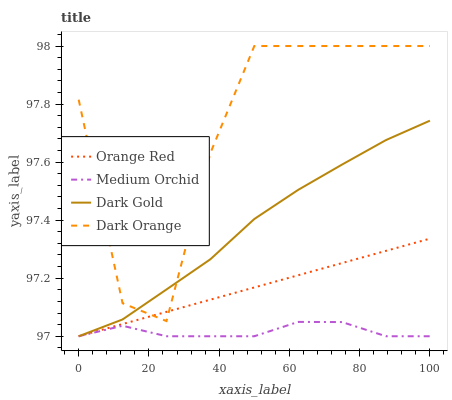Does Orange Red have the minimum area under the curve?
Answer yes or no. No. Does Orange Red have the maximum area under the curve?
Answer yes or no. No. Is Medium Orchid the smoothest?
Answer yes or no. No. Is Medium Orchid the roughest?
Answer yes or no. No. Does Orange Red have the highest value?
Answer yes or no. No. Is Medium Orchid less than Dark Orange?
Answer yes or no. Yes. Is Dark Orange greater than Medium Orchid?
Answer yes or no. Yes. Does Medium Orchid intersect Dark Orange?
Answer yes or no. No. 